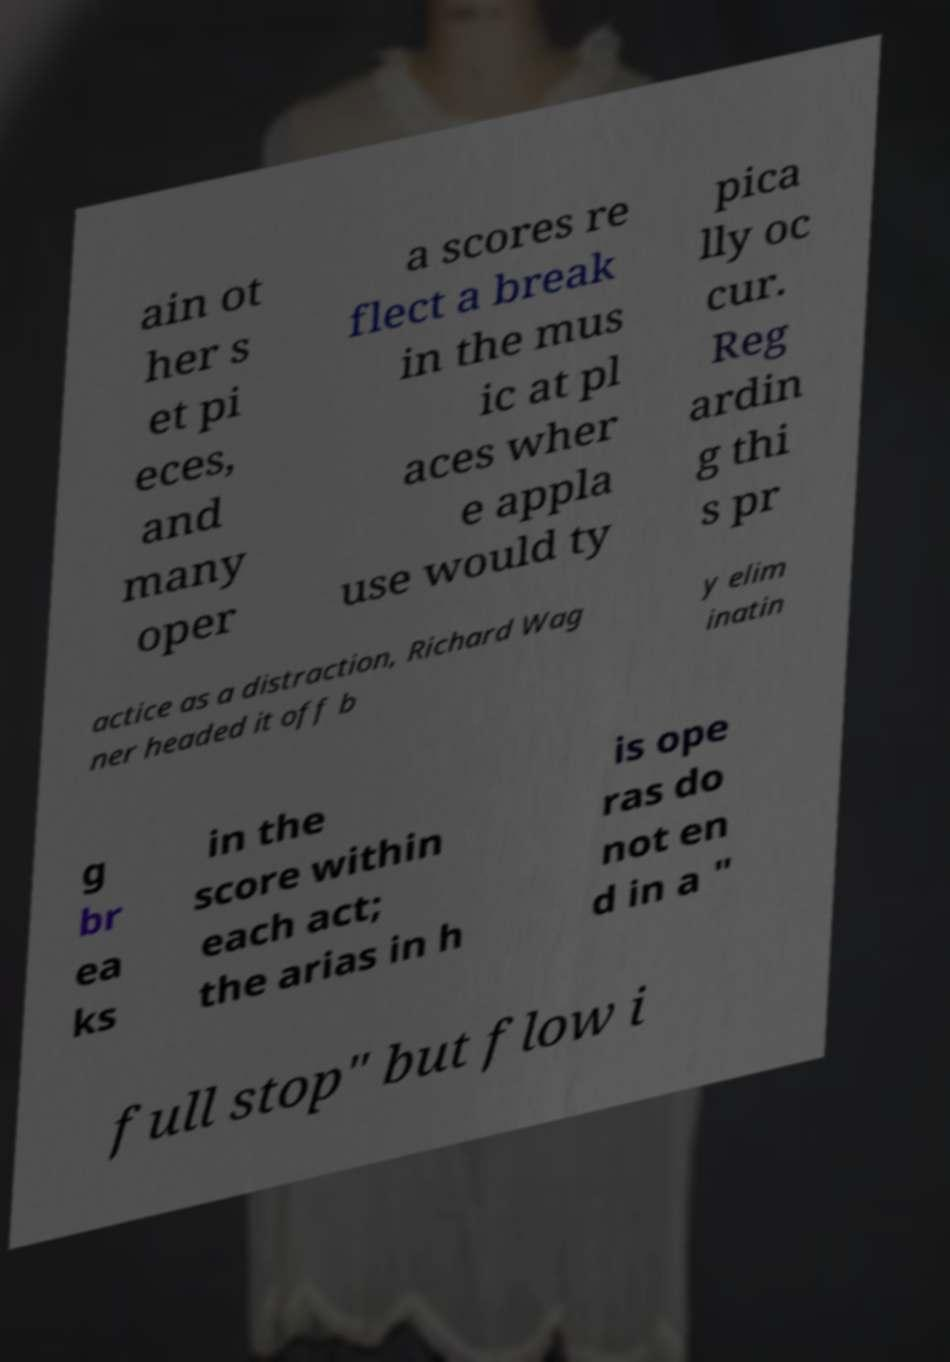I need the written content from this picture converted into text. Can you do that? ain ot her s et pi eces, and many oper a scores re flect a break in the mus ic at pl aces wher e appla use would ty pica lly oc cur. Reg ardin g thi s pr actice as a distraction, Richard Wag ner headed it off b y elim inatin g br ea ks in the score within each act; the arias in h is ope ras do not en d in a " full stop" but flow i 